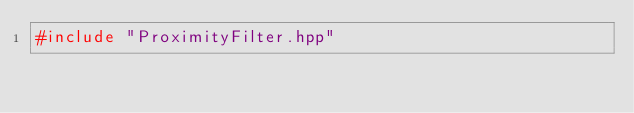<code> <loc_0><loc_0><loc_500><loc_500><_C++_>#include "ProximityFilter.hpp"
</code> 